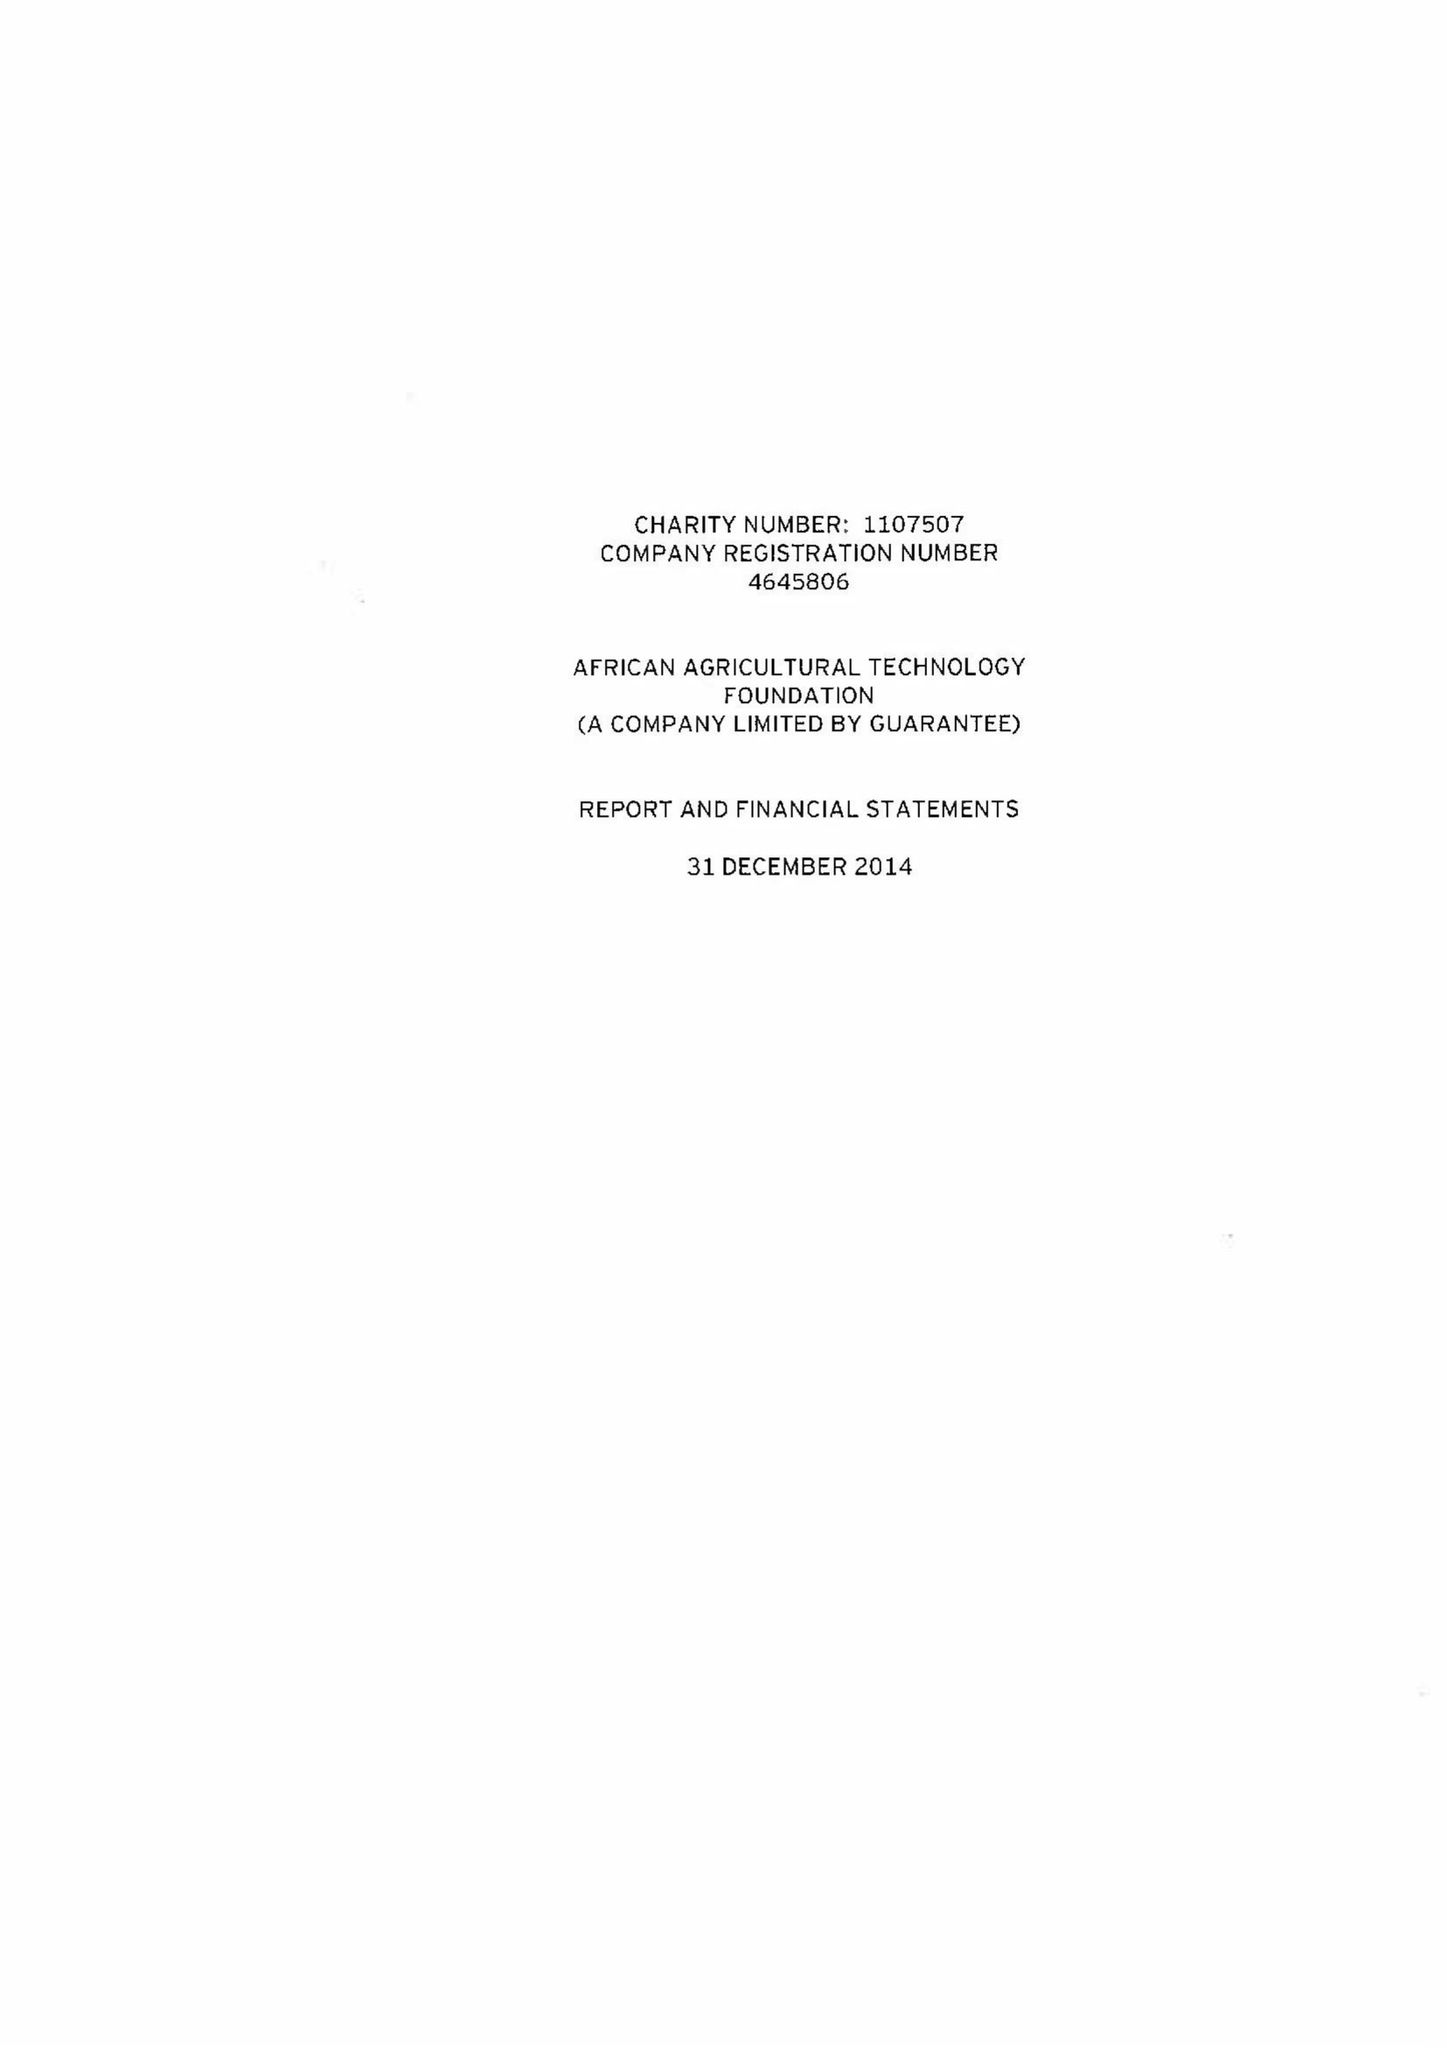What is the value for the address__street_line?
Answer the question using a single word or phrase. 25 OLD BROAD STREET 